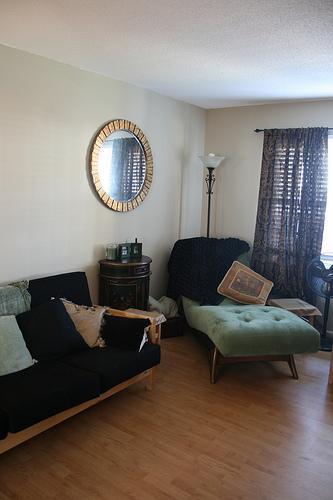How many mirrors are there?
Give a very brief answer. 1. 